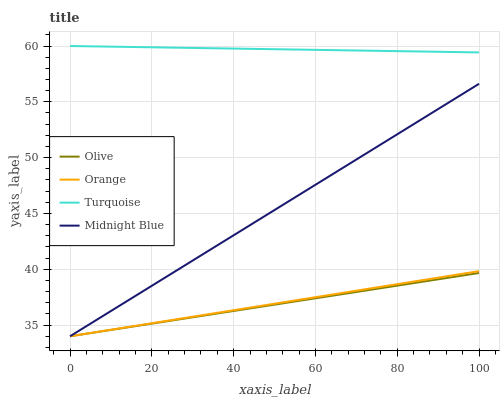Does Olive have the minimum area under the curve?
Answer yes or no. Yes. Does Turquoise have the maximum area under the curve?
Answer yes or no. Yes. Does Orange have the minimum area under the curve?
Answer yes or no. No. Does Orange have the maximum area under the curve?
Answer yes or no. No. Is Midnight Blue the smoothest?
Answer yes or no. Yes. Is Orange the roughest?
Answer yes or no. Yes. Is Turquoise the smoothest?
Answer yes or no. No. Is Turquoise the roughest?
Answer yes or no. No. Does Olive have the lowest value?
Answer yes or no. Yes. Does Turquoise have the lowest value?
Answer yes or no. No. Does Turquoise have the highest value?
Answer yes or no. Yes. Does Orange have the highest value?
Answer yes or no. No. Is Midnight Blue less than Turquoise?
Answer yes or no. Yes. Is Turquoise greater than Orange?
Answer yes or no. Yes. Does Olive intersect Midnight Blue?
Answer yes or no. Yes. Is Olive less than Midnight Blue?
Answer yes or no. No. Is Olive greater than Midnight Blue?
Answer yes or no. No. Does Midnight Blue intersect Turquoise?
Answer yes or no. No. 